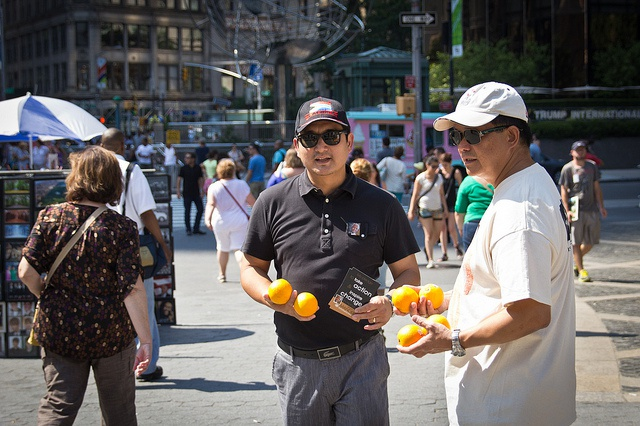Describe the objects in this image and their specific colors. I can see people in black, gray, brown, and darkgray tones, people in black, darkgray, white, brown, and gray tones, people in black and gray tones, people in black and gray tones, and people in black, gray, and maroon tones in this image. 